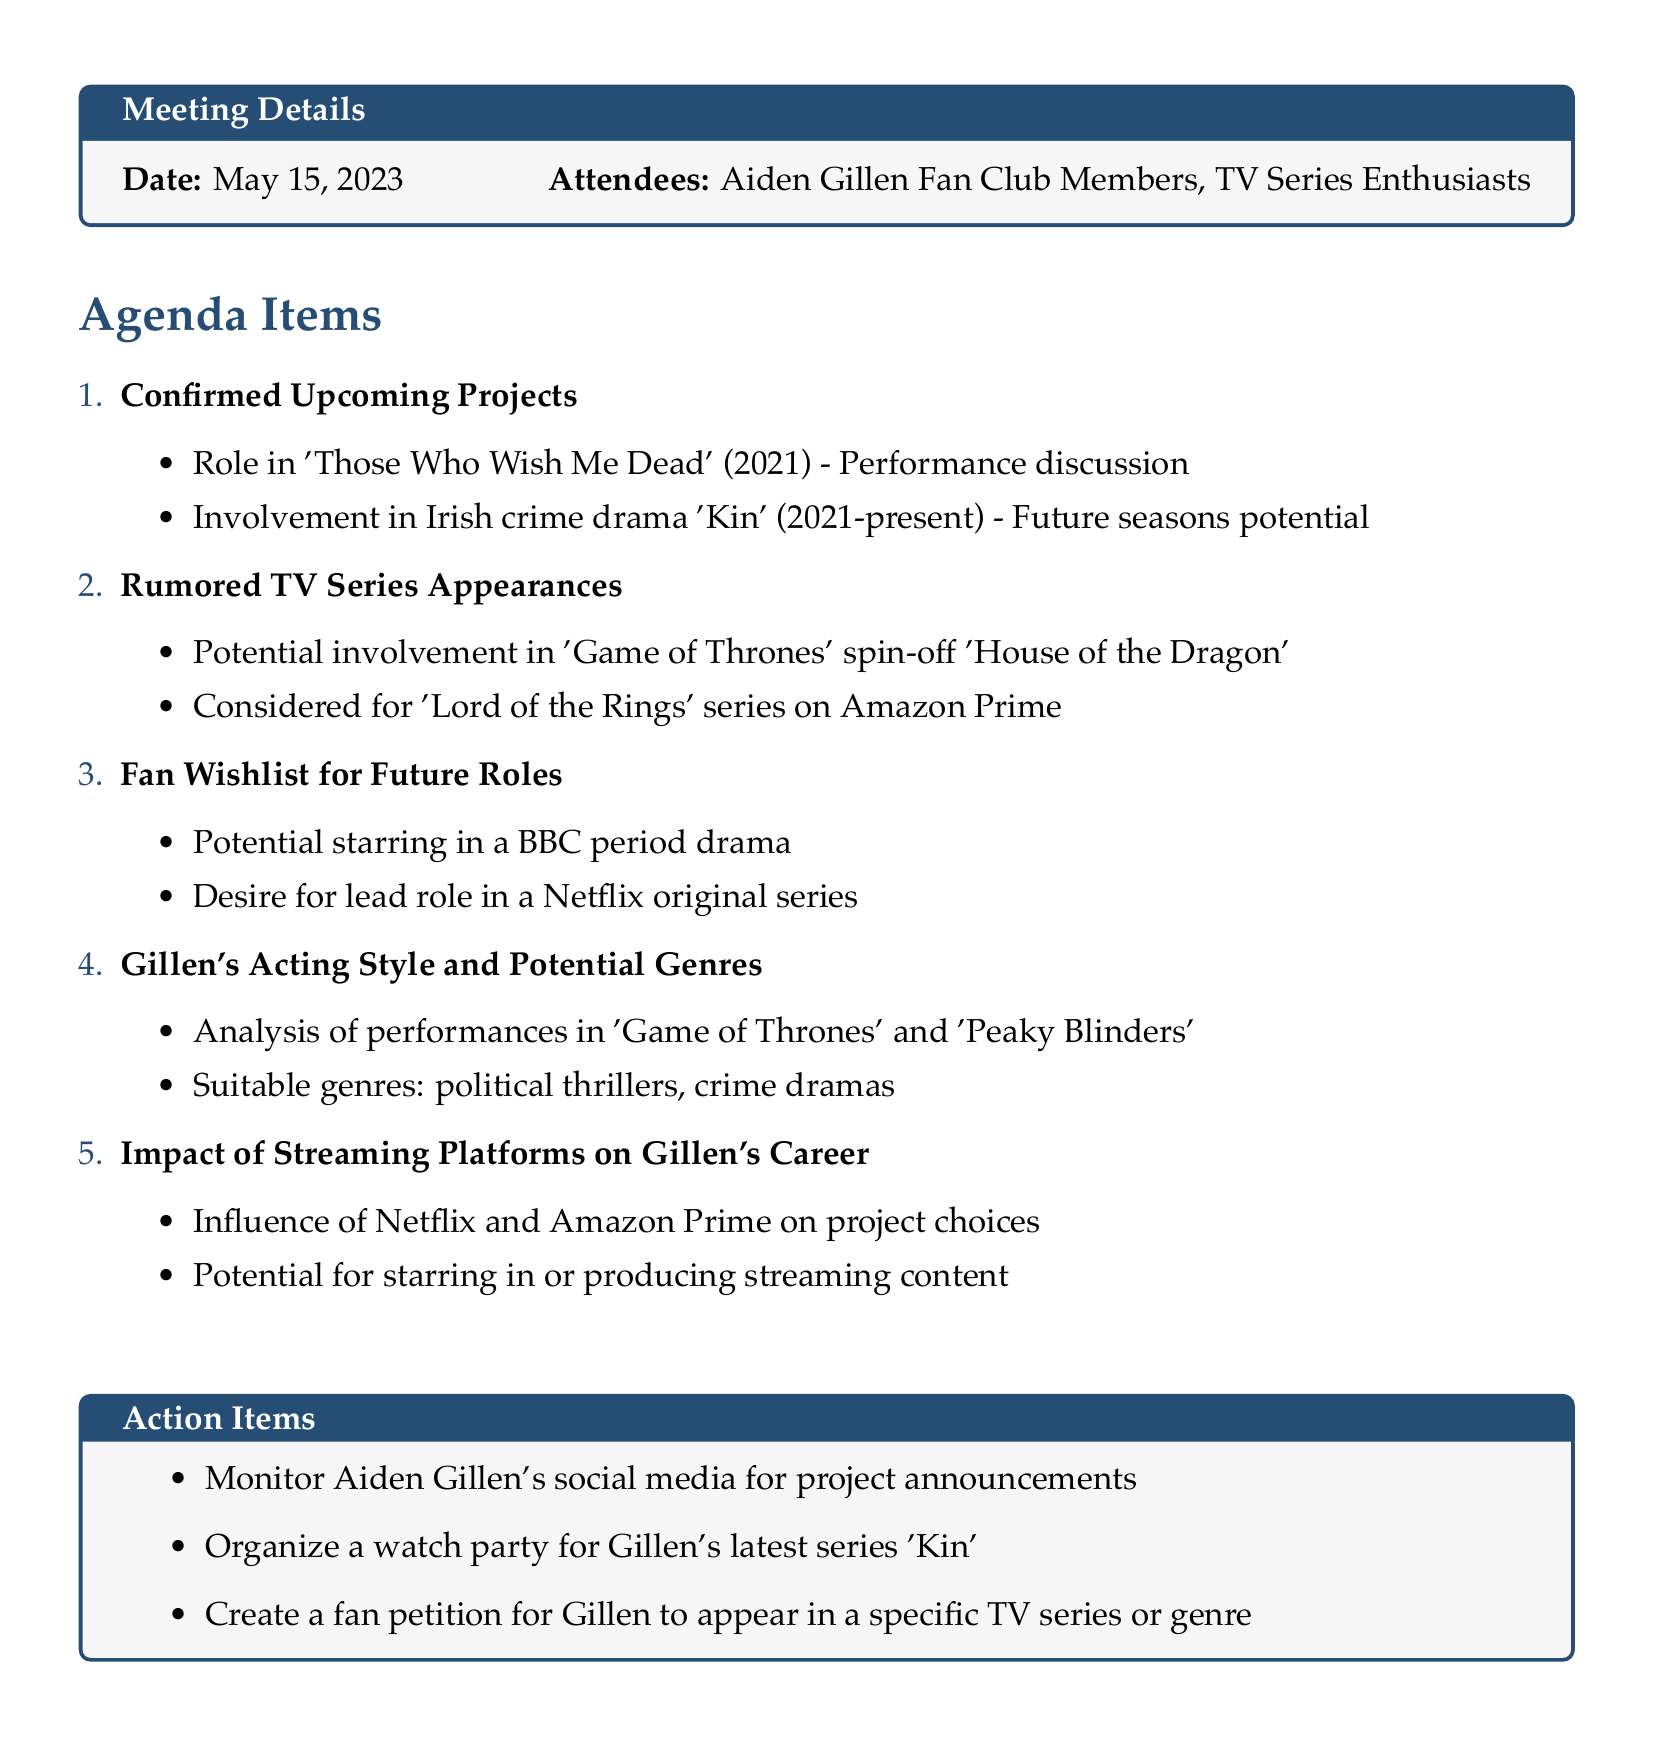What is the meeting date? The meeting date is specified in the document under Meeting Details.
Answer: May 15, 2023 Who are the attendees? The attendees are listed in the Meeting Details section.
Answer: Aiden Gillen Fan Club Members, TV Series Enthusiasts What is one of Aiden Gillen's confirmed projects? The confirmed projects are listed under Confirmed Upcoming Projects.
Answer: Those Who Wish Me Dead What TV series is Aiden Gillen rumored to be involved with? The rumored appearances are discussed under Rumored TV Series Appearances.
Answer: House of the Dragon What action item involves social media? The action items are clearly outlined at the end of the document.
Answer: Monitor Aiden Gillen's social media for project announcements Which genre do fans want to see Gillen in according to the wishlist? The fan wishlist includes specific genres in the Fan Wishlist for Future Roles section.
Answer: BBC period drama What impact might streaming platforms have on Gillen's career? The document discusses the influence of streaming platforms under Impact of Streaming Platforms on Gillen's Career.
Answer: Influence project choices What performance was analyzed in the acting style section? The acting style analysis includes performances listed in the Gillen's Acting Style and Potential Genres section.
Answer: Game of Thrones 